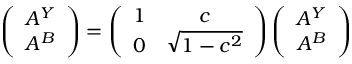<formula> <loc_0><loc_0><loc_500><loc_500>\left ( \begin{array} { c } { { A ^ { Y } } } \\ { { A ^ { B } } } \end{array} \right ) = \left ( \begin{array} { c c } { 1 } & { c } \\ { 0 } & { { \sqrt { 1 - c ^ { 2 } } } } \end{array} \right ) \left ( \begin{array} { c } { { A ^ { Y } } } \\ { { A ^ { B } } } \end{array} \right )</formula> 